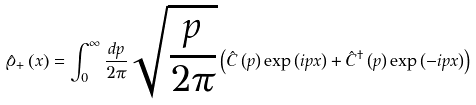<formula> <loc_0><loc_0><loc_500><loc_500>\hat { \varrho } _ { + } \left ( x \right ) = \int _ { 0 } ^ { \infty } \frac { d p } { 2 \pi } \sqrt { \frac { p } { 2 \pi } } \left ( \hat { C } \left ( p \right ) \exp { \left ( i p x \right ) } + \hat { C } ^ { \dag } \left ( p \right ) \exp { \left ( - i p x \right ) } \right )</formula> 